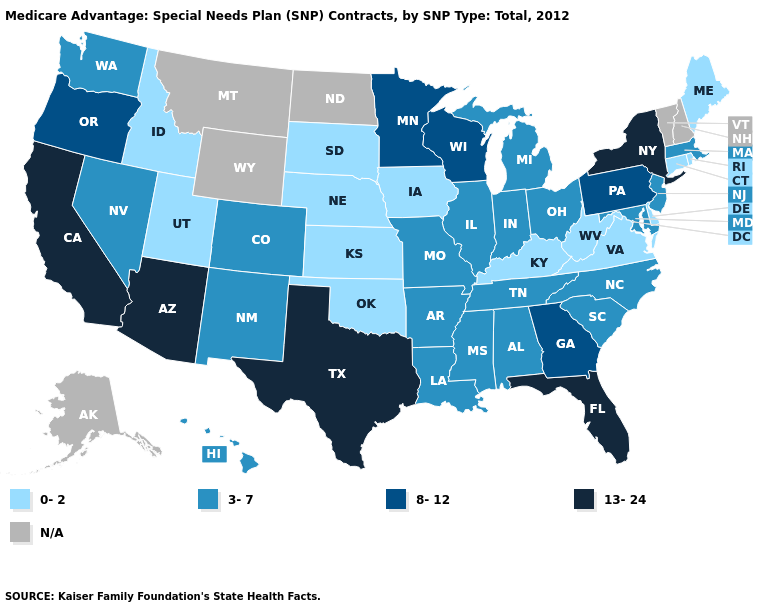What is the value of California?
Write a very short answer. 13-24. How many symbols are there in the legend?
Short answer required. 5. Which states have the lowest value in the West?
Answer briefly. Idaho, Utah. Name the states that have a value in the range N/A?
Be succinct. Alaska, Montana, North Dakota, New Hampshire, Vermont, Wyoming. How many symbols are there in the legend?
Concise answer only. 5. Which states hav the highest value in the MidWest?
Short answer required. Minnesota, Wisconsin. Name the states that have a value in the range 13-24?
Give a very brief answer. Arizona, California, Florida, New York, Texas. Name the states that have a value in the range 13-24?
Keep it brief. Arizona, California, Florida, New York, Texas. Is the legend a continuous bar?
Answer briefly. No. Which states hav the highest value in the South?
Quick response, please. Florida, Texas. Name the states that have a value in the range 13-24?
Answer briefly. Arizona, California, Florida, New York, Texas. Which states have the lowest value in the USA?
Write a very short answer. Connecticut, Delaware, Iowa, Idaho, Kansas, Kentucky, Maine, Nebraska, Oklahoma, Rhode Island, South Dakota, Utah, Virginia, West Virginia. Which states hav the highest value in the MidWest?
Be succinct. Minnesota, Wisconsin. What is the lowest value in states that border Iowa?
Quick response, please. 0-2. What is the highest value in the West ?
Concise answer only. 13-24. 